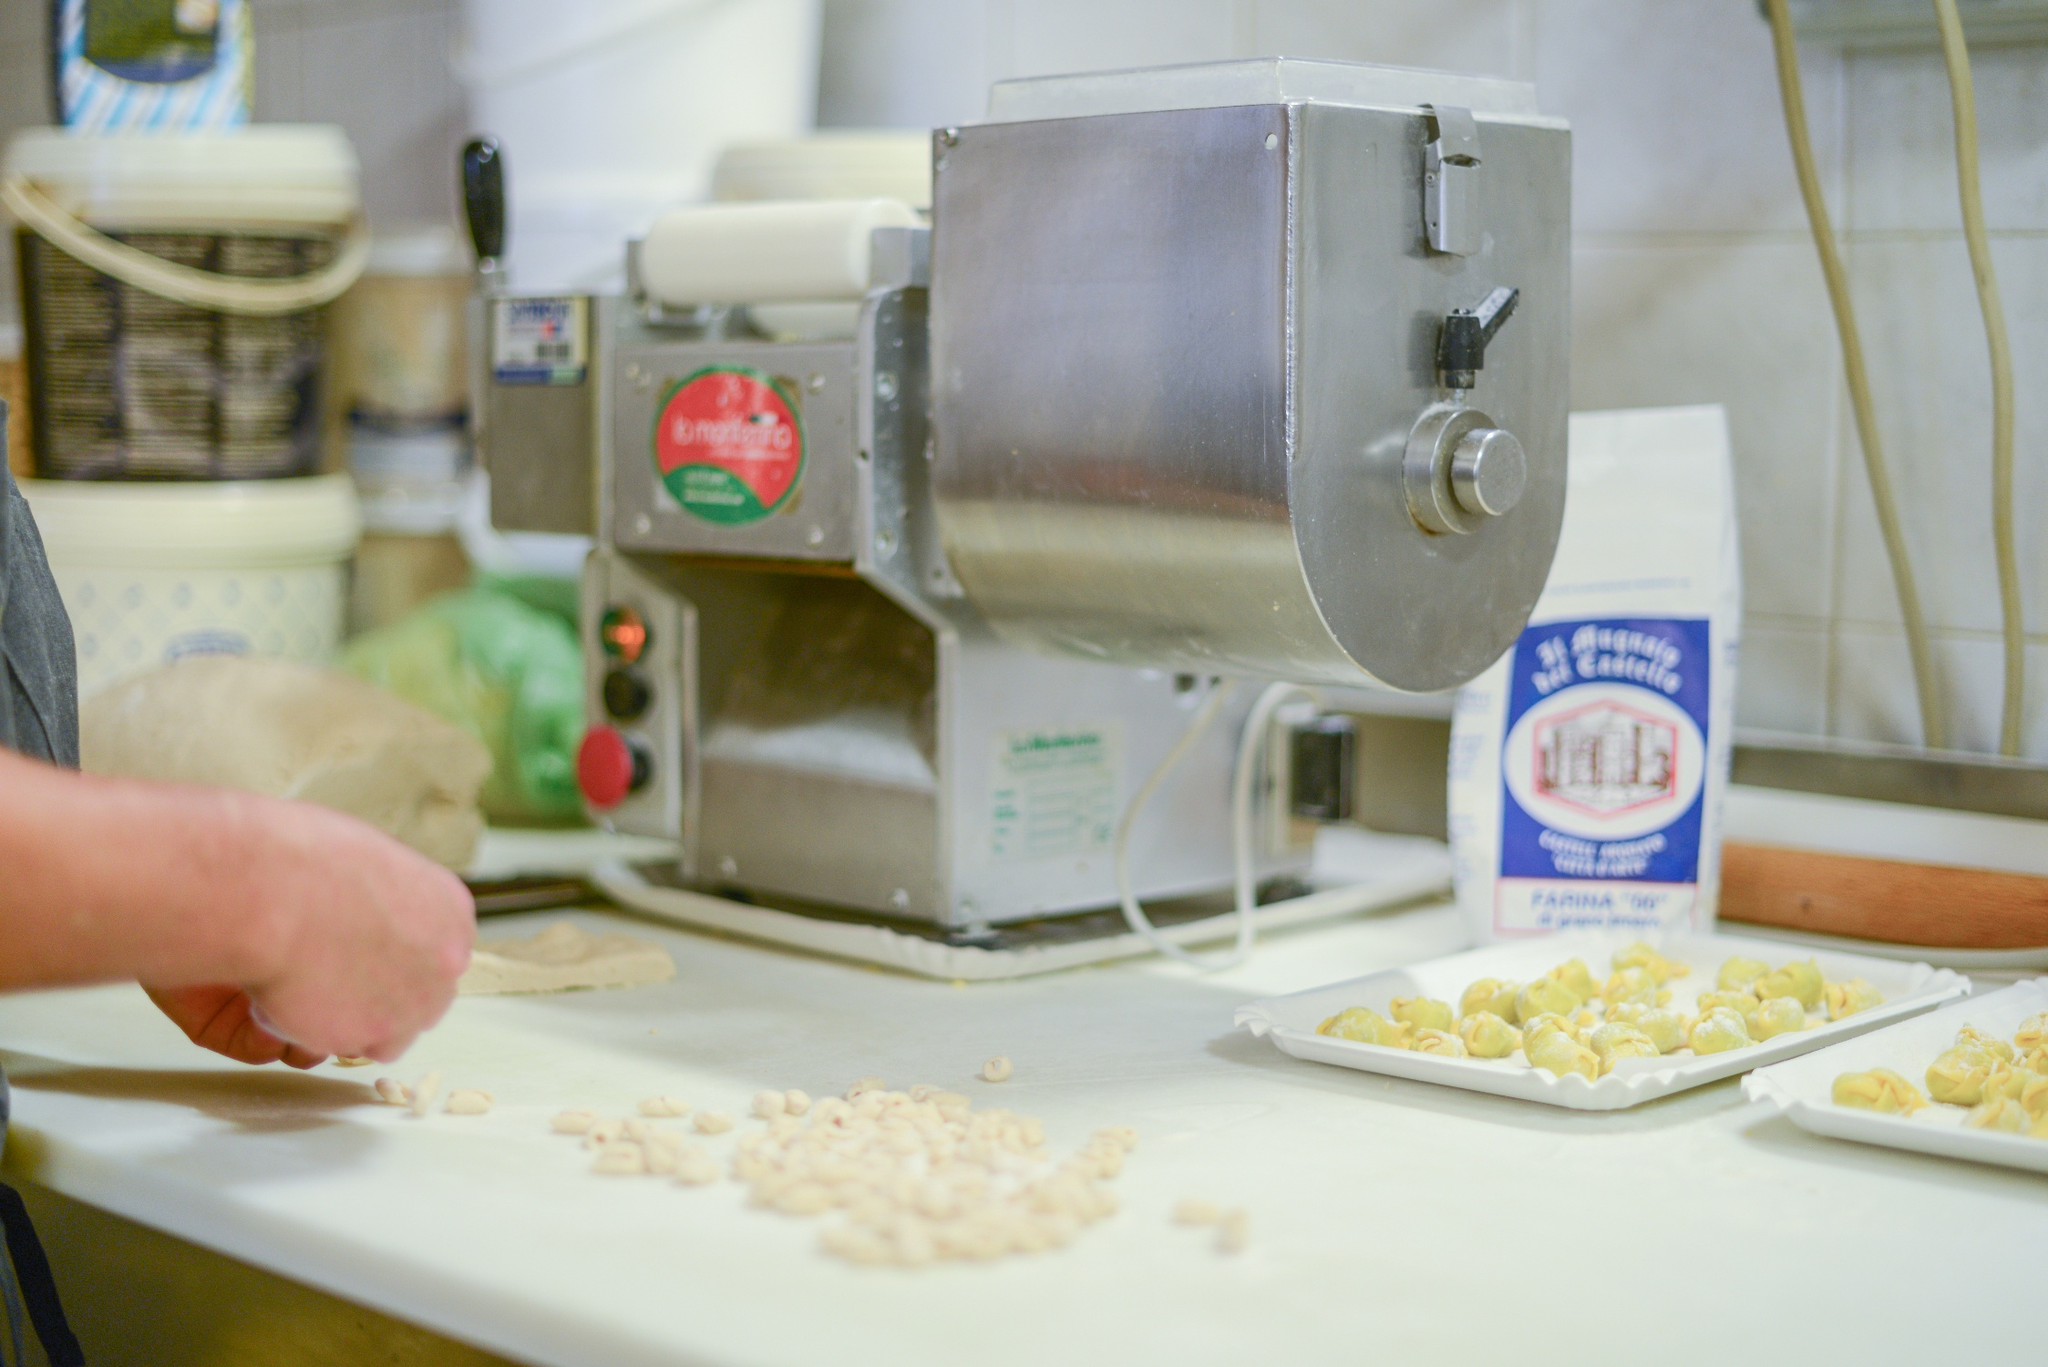What stories could this kitchen tell if it could speak? If this kitchen could speak, it would regale us with countless stories of culinary adventures, late-night cooking sessions, and festive family gatherings. It would share the secrets of cherished recipes passed down through generations, each pasta batch a labor of love and tradition. We’d hear about the joys of perfecting the art of pasta making, the occasional mishaps that led to laughter, and the triumphant moments of culinary success. This kitchen, with its pasta machine as a proud witness, has seen the blend of tradition and innovation, where every meal made is a celebration of heritage and togetherness. 